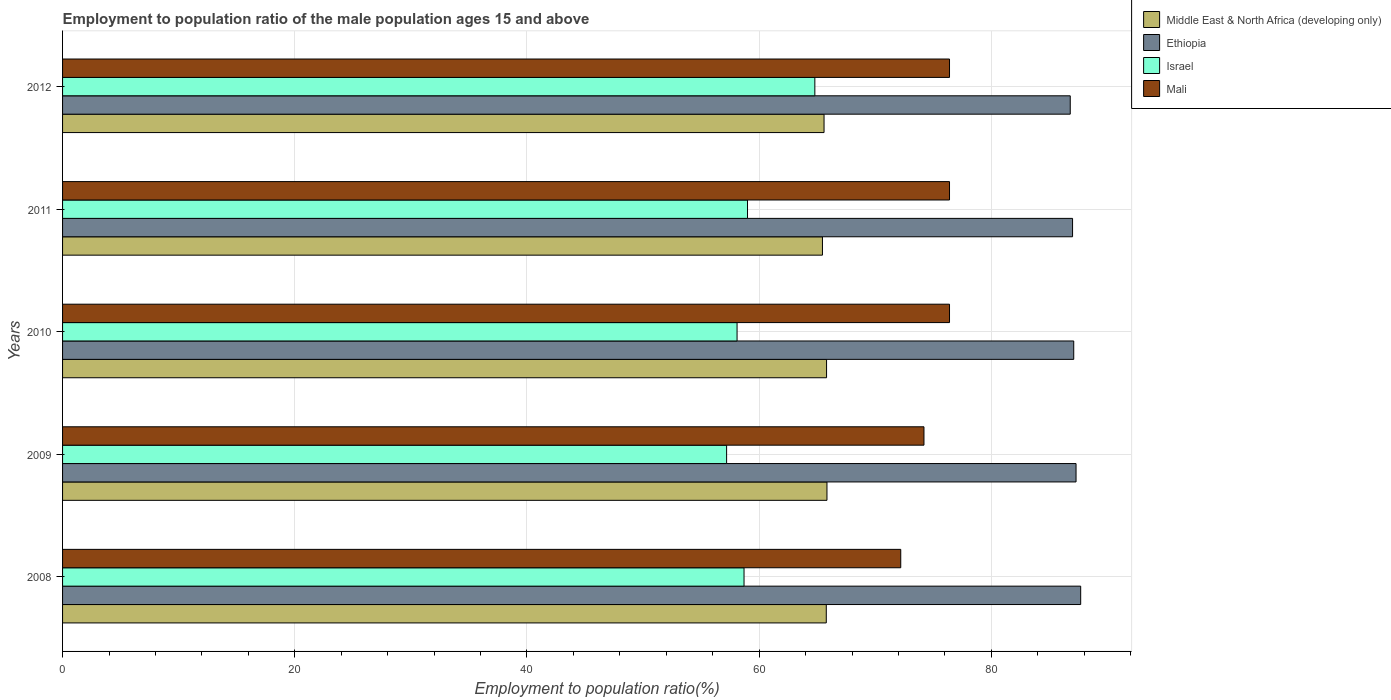Are the number of bars per tick equal to the number of legend labels?
Offer a very short reply. Yes. Are the number of bars on each tick of the Y-axis equal?
Provide a succinct answer. Yes. How many bars are there on the 2nd tick from the top?
Your response must be concise. 4. In how many cases, is the number of bars for a given year not equal to the number of legend labels?
Your answer should be compact. 0. What is the employment to population ratio in Mali in 2008?
Make the answer very short. 72.2. Across all years, what is the maximum employment to population ratio in Mali?
Make the answer very short. 76.4. Across all years, what is the minimum employment to population ratio in Israel?
Make the answer very short. 57.2. In which year was the employment to population ratio in Israel maximum?
Your answer should be very brief. 2012. What is the total employment to population ratio in Israel in the graph?
Make the answer very short. 297.8. What is the difference between the employment to population ratio in Middle East & North Africa (developing only) in 2008 and that in 2011?
Make the answer very short. 0.33. What is the difference between the employment to population ratio in Middle East & North Africa (developing only) in 2010 and the employment to population ratio in Mali in 2012?
Offer a terse response. -10.59. What is the average employment to population ratio in Middle East & North Africa (developing only) per year?
Provide a succinct answer. 65.7. In the year 2009, what is the difference between the employment to population ratio in Mali and employment to population ratio in Middle East & North Africa (developing only)?
Ensure brevity in your answer.  8.36. In how many years, is the employment to population ratio in Ethiopia greater than 48 %?
Your response must be concise. 5. What is the ratio of the employment to population ratio in Middle East & North Africa (developing only) in 2010 to that in 2011?
Provide a succinct answer. 1.01. What is the difference between the highest and the second highest employment to population ratio in Ethiopia?
Your answer should be compact. 0.4. What is the difference between the highest and the lowest employment to population ratio in Mali?
Your response must be concise. 4.2. What does the 3rd bar from the top in 2009 represents?
Give a very brief answer. Ethiopia. What does the 3rd bar from the bottom in 2012 represents?
Give a very brief answer. Israel. Is it the case that in every year, the sum of the employment to population ratio in Ethiopia and employment to population ratio in Israel is greater than the employment to population ratio in Mali?
Offer a terse response. Yes. How many bars are there?
Provide a short and direct response. 20. How many years are there in the graph?
Ensure brevity in your answer.  5. What is the difference between two consecutive major ticks on the X-axis?
Offer a terse response. 20. Are the values on the major ticks of X-axis written in scientific E-notation?
Give a very brief answer. No. Does the graph contain any zero values?
Your answer should be very brief. No. How are the legend labels stacked?
Your answer should be very brief. Vertical. What is the title of the graph?
Your response must be concise. Employment to population ratio of the male population ages 15 and above. Does "Germany" appear as one of the legend labels in the graph?
Make the answer very short. No. What is the label or title of the Y-axis?
Your answer should be very brief. Years. What is the Employment to population ratio(%) in Middle East & North Africa (developing only) in 2008?
Your answer should be very brief. 65.79. What is the Employment to population ratio(%) in Ethiopia in 2008?
Ensure brevity in your answer.  87.7. What is the Employment to population ratio(%) in Israel in 2008?
Ensure brevity in your answer.  58.7. What is the Employment to population ratio(%) of Mali in 2008?
Make the answer very short. 72.2. What is the Employment to population ratio(%) of Middle East & North Africa (developing only) in 2009?
Ensure brevity in your answer.  65.84. What is the Employment to population ratio(%) of Ethiopia in 2009?
Your response must be concise. 87.3. What is the Employment to population ratio(%) of Israel in 2009?
Offer a very short reply. 57.2. What is the Employment to population ratio(%) in Mali in 2009?
Keep it short and to the point. 74.2. What is the Employment to population ratio(%) of Middle East & North Africa (developing only) in 2010?
Keep it short and to the point. 65.81. What is the Employment to population ratio(%) in Ethiopia in 2010?
Give a very brief answer. 87.1. What is the Employment to population ratio(%) in Israel in 2010?
Offer a terse response. 58.1. What is the Employment to population ratio(%) in Mali in 2010?
Your response must be concise. 76.4. What is the Employment to population ratio(%) in Middle East & North Africa (developing only) in 2011?
Your answer should be very brief. 65.46. What is the Employment to population ratio(%) in Ethiopia in 2011?
Your answer should be compact. 87. What is the Employment to population ratio(%) in Israel in 2011?
Your answer should be very brief. 59. What is the Employment to population ratio(%) in Mali in 2011?
Your answer should be compact. 76.4. What is the Employment to population ratio(%) of Middle East & North Africa (developing only) in 2012?
Offer a very short reply. 65.59. What is the Employment to population ratio(%) of Ethiopia in 2012?
Make the answer very short. 86.8. What is the Employment to population ratio(%) in Israel in 2012?
Ensure brevity in your answer.  64.8. What is the Employment to population ratio(%) in Mali in 2012?
Provide a succinct answer. 76.4. Across all years, what is the maximum Employment to population ratio(%) in Middle East & North Africa (developing only)?
Provide a succinct answer. 65.84. Across all years, what is the maximum Employment to population ratio(%) in Ethiopia?
Provide a short and direct response. 87.7. Across all years, what is the maximum Employment to population ratio(%) of Israel?
Offer a very short reply. 64.8. Across all years, what is the maximum Employment to population ratio(%) in Mali?
Make the answer very short. 76.4. Across all years, what is the minimum Employment to population ratio(%) of Middle East & North Africa (developing only)?
Keep it short and to the point. 65.46. Across all years, what is the minimum Employment to population ratio(%) in Ethiopia?
Provide a short and direct response. 86.8. Across all years, what is the minimum Employment to population ratio(%) of Israel?
Your response must be concise. 57.2. Across all years, what is the minimum Employment to population ratio(%) in Mali?
Ensure brevity in your answer.  72.2. What is the total Employment to population ratio(%) of Middle East & North Africa (developing only) in the graph?
Offer a very short reply. 328.49. What is the total Employment to population ratio(%) in Ethiopia in the graph?
Your answer should be compact. 435.9. What is the total Employment to population ratio(%) in Israel in the graph?
Provide a short and direct response. 297.8. What is the total Employment to population ratio(%) of Mali in the graph?
Provide a short and direct response. 375.6. What is the difference between the Employment to population ratio(%) of Middle East & North Africa (developing only) in 2008 and that in 2009?
Ensure brevity in your answer.  -0.06. What is the difference between the Employment to population ratio(%) in Ethiopia in 2008 and that in 2009?
Ensure brevity in your answer.  0.4. What is the difference between the Employment to population ratio(%) of Middle East & North Africa (developing only) in 2008 and that in 2010?
Provide a short and direct response. -0.02. What is the difference between the Employment to population ratio(%) of Israel in 2008 and that in 2010?
Your answer should be very brief. 0.6. What is the difference between the Employment to population ratio(%) in Middle East & North Africa (developing only) in 2008 and that in 2011?
Keep it short and to the point. 0.33. What is the difference between the Employment to population ratio(%) of Ethiopia in 2008 and that in 2011?
Offer a terse response. 0.7. What is the difference between the Employment to population ratio(%) of Israel in 2008 and that in 2011?
Offer a terse response. -0.3. What is the difference between the Employment to population ratio(%) of Mali in 2008 and that in 2011?
Provide a succinct answer. -4.2. What is the difference between the Employment to population ratio(%) of Middle East & North Africa (developing only) in 2008 and that in 2012?
Ensure brevity in your answer.  0.19. What is the difference between the Employment to population ratio(%) in Ethiopia in 2008 and that in 2012?
Offer a very short reply. 0.9. What is the difference between the Employment to population ratio(%) of Israel in 2008 and that in 2012?
Offer a terse response. -6.1. What is the difference between the Employment to population ratio(%) of Mali in 2008 and that in 2012?
Your response must be concise. -4.2. What is the difference between the Employment to population ratio(%) in Middle East & North Africa (developing only) in 2009 and that in 2010?
Keep it short and to the point. 0.04. What is the difference between the Employment to population ratio(%) of Mali in 2009 and that in 2010?
Keep it short and to the point. -2.2. What is the difference between the Employment to population ratio(%) in Middle East & North Africa (developing only) in 2009 and that in 2011?
Make the answer very short. 0.39. What is the difference between the Employment to population ratio(%) of Israel in 2009 and that in 2011?
Keep it short and to the point. -1.8. What is the difference between the Employment to population ratio(%) of Mali in 2009 and that in 2011?
Provide a succinct answer. -2.2. What is the difference between the Employment to population ratio(%) in Middle East & North Africa (developing only) in 2009 and that in 2012?
Make the answer very short. 0.25. What is the difference between the Employment to population ratio(%) of Ethiopia in 2009 and that in 2012?
Give a very brief answer. 0.5. What is the difference between the Employment to population ratio(%) in Middle East & North Africa (developing only) in 2010 and that in 2011?
Ensure brevity in your answer.  0.35. What is the difference between the Employment to population ratio(%) of Ethiopia in 2010 and that in 2011?
Your answer should be compact. 0.1. What is the difference between the Employment to population ratio(%) of Israel in 2010 and that in 2011?
Ensure brevity in your answer.  -0.9. What is the difference between the Employment to population ratio(%) of Middle East & North Africa (developing only) in 2010 and that in 2012?
Your answer should be very brief. 0.22. What is the difference between the Employment to population ratio(%) in Mali in 2010 and that in 2012?
Offer a terse response. 0. What is the difference between the Employment to population ratio(%) in Middle East & North Africa (developing only) in 2011 and that in 2012?
Make the answer very short. -0.14. What is the difference between the Employment to population ratio(%) of Israel in 2011 and that in 2012?
Provide a short and direct response. -5.8. What is the difference between the Employment to population ratio(%) in Mali in 2011 and that in 2012?
Keep it short and to the point. 0. What is the difference between the Employment to population ratio(%) of Middle East & North Africa (developing only) in 2008 and the Employment to population ratio(%) of Ethiopia in 2009?
Your answer should be compact. -21.51. What is the difference between the Employment to population ratio(%) of Middle East & North Africa (developing only) in 2008 and the Employment to population ratio(%) of Israel in 2009?
Your answer should be compact. 8.59. What is the difference between the Employment to population ratio(%) of Middle East & North Africa (developing only) in 2008 and the Employment to population ratio(%) of Mali in 2009?
Offer a terse response. -8.41. What is the difference between the Employment to population ratio(%) in Ethiopia in 2008 and the Employment to population ratio(%) in Israel in 2009?
Your response must be concise. 30.5. What is the difference between the Employment to population ratio(%) of Ethiopia in 2008 and the Employment to population ratio(%) of Mali in 2009?
Ensure brevity in your answer.  13.5. What is the difference between the Employment to population ratio(%) in Israel in 2008 and the Employment to population ratio(%) in Mali in 2009?
Offer a very short reply. -15.5. What is the difference between the Employment to population ratio(%) in Middle East & North Africa (developing only) in 2008 and the Employment to population ratio(%) in Ethiopia in 2010?
Provide a succinct answer. -21.31. What is the difference between the Employment to population ratio(%) in Middle East & North Africa (developing only) in 2008 and the Employment to population ratio(%) in Israel in 2010?
Make the answer very short. 7.69. What is the difference between the Employment to population ratio(%) in Middle East & North Africa (developing only) in 2008 and the Employment to population ratio(%) in Mali in 2010?
Provide a short and direct response. -10.61. What is the difference between the Employment to population ratio(%) in Ethiopia in 2008 and the Employment to population ratio(%) in Israel in 2010?
Offer a terse response. 29.6. What is the difference between the Employment to population ratio(%) in Ethiopia in 2008 and the Employment to population ratio(%) in Mali in 2010?
Your answer should be very brief. 11.3. What is the difference between the Employment to population ratio(%) in Israel in 2008 and the Employment to population ratio(%) in Mali in 2010?
Your answer should be compact. -17.7. What is the difference between the Employment to population ratio(%) in Middle East & North Africa (developing only) in 2008 and the Employment to population ratio(%) in Ethiopia in 2011?
Your response must be concise. -21.21. What is the difference between the Employment to population ratio(%) in Middle East & North Africa (developing only) in 2008 and the Employment to population ratio(%) in Israel in 2011?
Make the answer very short. 6.79. What is the difference between the Employment to population ratio(%) in Middle East & North Africa (developing only) in 2008 and the Employment to population ratio(%) in Mali in 2011?
Offer a terse response. -10.61. What is the difference between the Employment to population ratio(%) of Ethiopia in 2008 and the Employment to population ratio(%) of Israel in 2011?
Your answer should be compact. 28.7. What is the difference between the Employment to population ratio(%) of Ethiopia in 2008 and the Employment to population ratio(%) of Mali in 2011?
Make the answer very short. 11.3. What is the difference between the Employment to population ratio(%) in Israel in 2008 and the Employment to population ratio(%) in Mali in 2011?
Ensure brevity in your answer.  -17.7. What is the difference between the Employment to population ratio(%) of Middle East & North Africa (developing only) in 2008 and the Employment to population ratio(%) of Ethiopia in 2012?
Your response must be concise. -21.01. What is the difference between the Employment to population ratio(%) of Middle East & North Africa (developing only) in 2008 and the Employment to population ratio(%) of Israel in 2012?
Your response must be concise. 0.99. What is the difference between the Employment to population ratio(%) in Middle East & North Africa (developing only) in 2008 and the Employment to population ratio(%) in Mali in 2012?
Ensure brevity in your answer.  -10.61. What is the difference between the Employment to population ratio(%) of Ethiopia in 2008 and the Employment to population ratio(%) of Israel in 2012?
Provide a succinct answer. 22.9. What is the difference between the Employment to population ratio(%) in Ethiopia in 2008 and the Employment to population ratio(%) in Mali in 2012?
Make the answer very short. 11.3. What is the difference between the Employment to population ratio(%) in Israel in 2008 and the Employment to population ratio(%) in Mali in 2012?
Offer a terse response. -17.7. What is the difference between the Employment to population ratio(%) of Middle East & North Africa (developing only) in 2009 and the Employment to population ratio(%) of Ethiopia in 2010?
Offer a terse response. -21.26. What is the difference between the Employment to population ratio(%) in Middle East & North Africa (developing only) in 2009 and the Employment to population ratio(%) in Israel in 2010?
Your response must be concise. 7.74. What is the difference between the Employment to population ratio(%) in Middle East & North Africa (developing only) in 2009 and the Employment to population ratio(%) in Mali in 2010?
Your answer should be compact. -10.56. What is the difference between the Employment to population ratio(%) in Ethiopia in 2009 and the Employment to population ratio(%) in Israel in 2010?
Provide a short and direct response. 29.2. What is the difference between the Employment to population ratio(%) of Ethiopia in 2009 and the Employment to population ratio(%) of Mali in 2010?
Give a very brief answer. 10.9. What is the difference between the Employment to population ratio(%) of Israel in 2009 and the Employment to population ratio(%) of Mali in 2010?
Offer a terse response. -19.2. What is the difference between the Employment to population ratio(%) of Middle East & North Africa (developing only) in 2009 and the Employment to population ratio(%) of Ethiopia in 2011?
Make the answer very short. -21.16. What is the difference between the Employment to population ratio(%) in Middle East & North Africa (developing only) in 2009 and the Employment to population ratio(%) in Israel in 2011?
Provide a succinct answer. 6.84. What is the difference between the Employment to population ratio(%) of Middle East & North Africa (developing only) in 2009 and the Employment to population ratio(%) of Mali in 2011?
Offer a terse response. -10.56. What is the difference between the Employment to population ratio(%) of Ethiopia in 2009 and the Employment to population ratio(%) of Israel in 2011?
Provide a succinct answer. 28.3. What is the difference between the Employment to population ratio(%) of Israel in 2009 and the Employment to population ratio(%) of Mali in 2011?
Your answer should be very brief. -19.2. What is the difference between the Employment to population ratio(%) in Middle East & North Africa (developing only) in 2009 and the Employment to population ratio(%) in Ethiopia in 2012?
Provide a succinct answer. -20.96. What is the difference between the Employment to population ratio(%) in Middle East & North Africa (developing only) in 2009 and the Employment to population ratio(%) in Israel in 2012?
Provide a succinct answer. 1.04. What is the difference between the Employment to population ratio(%) of Middle East & North Africa (developing only) in 2009 and the Employment to population ratio(%) of Mali in 2012?
Provide a short and direct response. -10.56. What is the difference between the Employment to population ratio(%) in Ethiopia in 2009 and the Employment to population ratio(%) in Mali in 2012?
Ensure brevity in your answer.  10.9. What is the difference between the Employment to population ratio(%) in Israel in 2009 and the Employment to population ratio(%) in Mali in 2012?
Give a very brief answer. -19.2. What is the difference between the Employment to population ratio(%) in Middle East & North Africa (developing only) in 2010 and the Employment to population ratio(%) in Ethiopia in 2011?
Give a very brief answer. -21.19. What is the difference between the Employment to population ratio(%) in Middle East & North Africa (developing only) in 2010 and the Employment to population ratio(%) in Israel in 2011?
Your answer should be compact. 6.81. What is the difference between the Employment to population ratio(%) of Middle East & North Africa (developing only) in 2010 and the Employment to population ratio(%) of Mali in 2011?
Ensure brevity in your answer.  -10.59. What is the difference between the Employment to population ratio(%) of Ethiopia in 2010 and the Employment to population ratio(%) of Israel in 2011?
Make the answer very short. 28.1. What is the difference between the Employment to population ratio(%) of Ethiopia in 2010 and the Employment to population ratio(%) of Mali in 2011?
Make the answer very short. 10.7. What is the difference between the Employment to population ratio(%) of Israel in 2010 and the Employment to population ratio(%) of Mali in 2011?
Offer a terse response. -18.3. What is the difference between the Employment to population ratio(%) of Middle East & North Africa (developing only) in 2010 and the Employment to population ratio(%) of Ethiopia in 2012?
Your answer should be compact. -20.99. What is the difference between the Employment to population ratio(%) of Middle East & North Africa (developing only) in 2010 and the Employment to population ratio(%) of Israel in 2012?
Your response must be concise. 1.01. What is the difference between the Employment to population ratio(%) of Middle East & North Africa (developing only) in 2010 and the Employment to population ratio(%) of Mali in 2012?
Offer a terse response. -10.59. What is the difference between the Employment to population ratio(%) of Ethiopia in 2010 and the Employment to population ratio(%) of Israel in 2012?
Offer a terse response. 22.3. What is the difference between the Employment to population ratio(%) of Ethiopia in 2010 and the Employment to population ratio(%) of Mali in 2012?
Offer a terse response. 10.7. What is the difference between the Employment to population ratio(%) in Israel in 2010 and the Employment to population ratio(%) in Mali in 2012?
Your response must be concise. -18.3. What is the difference between the Employment to population ratio(%) in Middle East & North Africa (developing only) in 2011 and the Employment to population ratio(%) in Ethiopia in 2012?
Provide a short and direct response. -21.34. What is the difference between the Employment to population ratio(%) in Middle East & North Africa (developing only) in 2011 and the Employment to population ratio(%) in Israel in 2012?
Give a very brief answer. 0.66. What is the difference between the Employment to population ratio(%) of Middle East & North Africa (developing only) in 2011 and the Employment to population ratio(%) of Mali in 2012?
Your answer should be compact. -10.94. What is the difference between the Employment to population ratio(%) of Ethiopia in 2011 and the Employment to population ratio(%) of Israel in 2012?
Your answer should be compact. 22.2. What is the difference between the Employment to population ratio(%) of Ethiopia in 2011 and the Employment to population ratio(%) of Mali in 2012?
Offer a very short reply. 10.6. What is the difference between the Employment to population ratio(%) in Israel in 2011 and the Employment to population ratio(%) in Mali in 2012?
Provide a succinct answer. -17.4. What is the average Employment to population ratio(%) in Middle East & North Africa (developing only) per year?
Make the answer very short. 65.7. What is the average Employment to population ratio(%) of Ethiopia per year?
Your response must be concise. 87.18. What is the average Employment to population ratio(%) in Israel per year?
Keep it short and to the point. 59.56. What is the average Employment to population ratio(%) in Mali per year?
Make the answer very short. 75.12. In the year 2008, what is the difference between the Employment to population ratio(%) of Middle East & North Africa (developing only) and Employment to population ratio(%) of Ethiopia?
Keep it short and to the point. -21.91. In the year 2008, what is the difference between the Employment to population ratio(%) of Middle East & North Africa (developing only) and Employment to population ratio(%) of Israel?
Your response must be concise. 7.09. In the year 2008, what is the difference between the Employment to population ratio(%) in Middle East & North Africa (developing only) and Employment to population ratio(%) in Mali?
Provide a short and direct response. -6.41. In the year 2008, what is the difference between the Employment to population ratio(%) of Ethiopia and Employment to population ratio(%) of Israel?
Give a very brief answer. 29. In the year 2008, what is the difference between the Employment to population ratio(%) of Ethiopia and Employment to population ratio(%) of Mali?
Your answer should be very brief. 15.5. In the year 2009, what is the difference between the Employment to population ratio(%) in Middle East & North Africa (developing only) and Employment to population ratio(%) in Ethiopia?
Offer a terse response. -21.46. In the year 2009, what is the difference between the Employment to population ratio(%) in Middle East & North Africa (developing only) and Employment to population ratio(%) in Israel?
Keep it short and to the point. 8.64. In the year 2009, what is the difference between the Employment to population ratio(%) in Middle East & North Africa (developing only) and Employment to population ratio(%) in Mali?
Make the answer very short. -8.36. In the year 2009, what is the difference between the Employment to population ratio(%) in Ethiopia and Employment to population ratio(%) in Israel?
Keep it short and to the point. 30.1. In the year 2009, what is the difference between the Employment to population ratio(%) in Israel and Employment to population ratio(%) in Mali?
Provide a succinct answer. -17. In the year 2010, what is the difference between the Employment to population ratio(%) of Middle East & North Africa (developing only) and Employment to population ratio(%) of Ethiopia?
Offer a very short reply. -21.29. In the year 2010, what is the difference between the Employment to population ratio(%) in Middle East & North Africa (developing only) and Employment to population ratio(%) in Israel?
Offer a very short reply. 7.71. In the year 2010, what is the difference between the Employment to population ratio(%) in Middle East & North Africa (developing only) and Employment to population ratio(%) in Mali?
Provide a short and direct response. -10.59. In the year 2010, what is the difference between the Employment to population ratio(%) in Ethiopia and Employment to population ratio(%) in Mali?
Provide a short and direct response. 10.7. In the year 2010, what is the difference between the Employment to population ratio(%) in Israel and Employment to population ratio(%) in Mali?
Offer a terse response. -18.3. In the year 2011, what is the difference between the Employment to population ratio(%) in Middle East & North Africa (developing only) and Employment to population ratio(%) in Ethiopia?
Offer a very short reply. -21.54. In the year 2011, what is the difference between the Employment to population ratio(%) of Middle East & North Africa (developing only) and Employment to population ratio(%) of Israel?
Provide a short and direct response. 6.46. In the year 2011, what is the difference between the Employment to population ratio(%) of Middle East & North Africa (developing only) and Employment to population ratio(%) of Mali?
Offer a terse response. -10.94. In the year 2011, what is the difference between the Employment to population ratio(%) in Ethiopia and Employment to population ratio(%) in Mali?
Keep it short and to the point. 10.6. In the year 2011, what is the difference between the Employment to population ratio(%) of Israel and Employment to population ratio(%) of Mali?
Ensure brevity in your answer.  -17.4. In the year 2012, what is the difference between the Employment to population ratio(%) of Middle East & North Africa (developing only) and Employment to population ratio(%) of Ethiopia?
Your answer should be very brief. -21.21. In the year 2012, what is the difference between the Employment to population ratio(%) in Middle East & North Africa (developing only) and Employment to population ratio(%) in Israel?
Offer a very short reply. 0.79. In the year 2012, what is the difference between the Employment to population ratio(%) in Middle East & North Africa (developing only) and Employment to population ratio(%) in Mali?
Make the answer very short. -10.81. In the year 2012, what is the difference between the Employment to population ratio(%) in Ethiopia and Employment to population ratio(%) in Israel?
Keep it short and to the point. 22. In the year 2012, what is the difference between the Employment to population ratio(%) of Ethiopia and Employment to population ratio(%) of Mali?
Offer a terse response. 10.4. What is the ratio of the Employment to population ratio(%) of Middle East & North Africa (developing only) in 2008 to that in 2009?
Your answer should be very brief. 1. What is the ratio of the Employment to population ratio(%) in Ethiopia in 2008 to that in 2009?
Your answer should be compact. 1. What is the ratio of the Employment to population ratio(%) in Israel in 2008 to that in 2009?
Your response must be concise. 1.03. What is the ratio of the Employment to population ratio(%) in Mali in 2008 to that in 2009?
Provide a succinct answer. 0.97. What is the ratio of the Employment to population ratio(%) in Israel in 2008 to that in 2010?
Provide a succinct answer. 1.01. What is the ratio of the Employment to population ratio(%) in Mali in 2008 to that in 2010?
Ensure brevity in your answer.  0.94. What is the ratio of the Employment to population ratio(%) of Middle East & North Africa (developing only) in 2008 to that in 2011?
Keep it short and to the point. 1. What is the ratio of the Employment to population ratio(%) in Israel in 2008 to that in 2011?
Provide a short and direct response. 0.99. What is the ratio of the Employment to population ratio(%) in Mali in 2008 to that in 2011?
Ensure brevity in your answer.  0.94. What is the ratio of the Employment to population ratio(%) in Ethiopia in 2008 to that in 2012?
Offer a terse response. 1.01. What is the ratio of the Employment to population ratio(%) of Israel in 2008 to that in 2012?
Your response must be concise. 0.91. What is the ratio of the Employment to population ratio(%) of Mali in 2008 to that in 2012?
Your answer should be very brief. 0.94. What is the ratio of the Employment to population ratio(%) in Israel in 2009 to that in 2010?
Provide a short and direct response. 0.98. What is the ratio of the Employment to population ratio(%) in Mali in 2009 to that in 2010?
Your answer should be compact. 0.97. What is the ratio of the Employment to population ratio(%) in Middle East & North Africa (developing only) in 2009 to that in 2011?
Provide a short and direct response. 1.01. What is the ratio of the Employment to population ratio(%) in Israel in 2009 to that in 2011?
Provide a succinct answer. 0.97. What is the ratio of the Employment to population ratio(%) of Mali in 2009 to that in 2011?
Provide a succinct answer. 0.97. What is the ratio of the Employment to population ratio(%) in Ethiopia in 2009 to that in 2012?
Offer a terse response. 1.01. What is the ratio of the Employment to population ratio(%) of Israel in 2009 to that in 2012?
Provide a succinct answer. 0.88. What is the ratio of the Employment to population ratio(%) in Mali in 2009 to that in 2012?
Ensure brevity in your answer.  0.97. What is the ratio of the Employment to population ratio(%) in Middle East & North Africa (developing only) in 2010 to that in 2011?
Your answer should be compact. 1.01. What is the ratio of the Employment to population ratio(%) in Israel in 2010 to that in 2011?
Keep it short and to the point. 0.98. What is the ratio of the Employment to population ratio(%) of Middle East & North Africa (developing only) in 2010 to that in 2012?
Provide a short and direct response. 1. What is the ratio of the Employment to population ratio(%) of Ethiopia in 2010 to that in 2012?
Offer a very short reply. 1. What is the ratio of the Employment to population ratio(%) in Israel in 2010 to that in 2012?
Ensure brevity in your answer.  0.9. What is the ratio of the Employment to population ratio(%) in Mali in 2010 to that in 2012?
Offer a terse response. 1. What is the ratio of the Employment to population ratio(%) in Middle East & North Africa (developing only) in 2011 to that in 2012?
Ensure brevity in your answer.  1. What is the ratio of the Employment to population ratio(%) in Israel in 2011 to that in 2012?
Your response must be concise. 0.91. What is the ratio of the Employment to population ratio(%) in Mali in 2011 to that in 2012?
Offer a very short reply. 1. What is the difference between the highest and the second highest Employment to population ratio(%) of Middle East & North Africa (developing only)?
Provide a short and direct response. 0.04. What is the difference between the highest and the second highest Employment to population ratio(%) of Ethiopia?
Provide a short and direct response. 0.4. What is the difference between the highest and the lowest Employment to population ratio(%) of Middle East & North Africa (developing only)?
Provide a succinct answer. 0.39. What is the difference between the highest and the lowest Employment to population ratio(%) of Ethiopia?
Keep it short and to the point. 0.9. What is the difference between the highest and the lowest Employment to population ratio(%) in Israel?
Offer a very short reply. 7.6. What is the difference between the highest and the lowest Employment to population ratio(%) of Mali?
Provide a short and direct response. 4.2. 